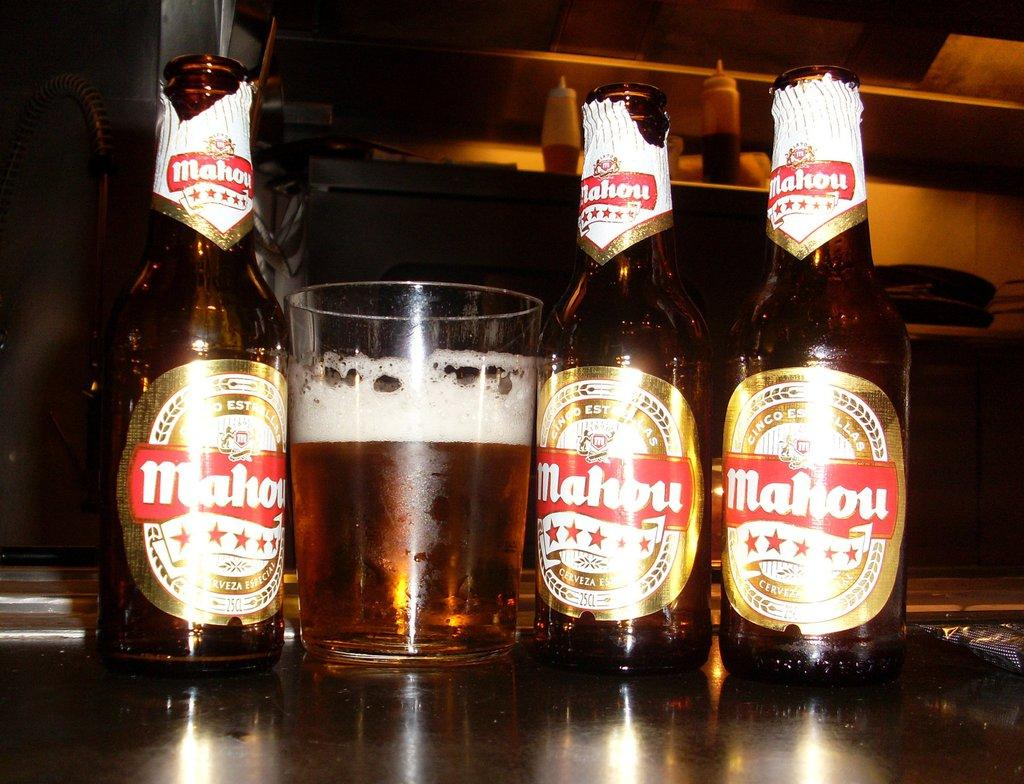<image>
Describe the image concisely. three bottles of Mahou beer next to a glass of it 